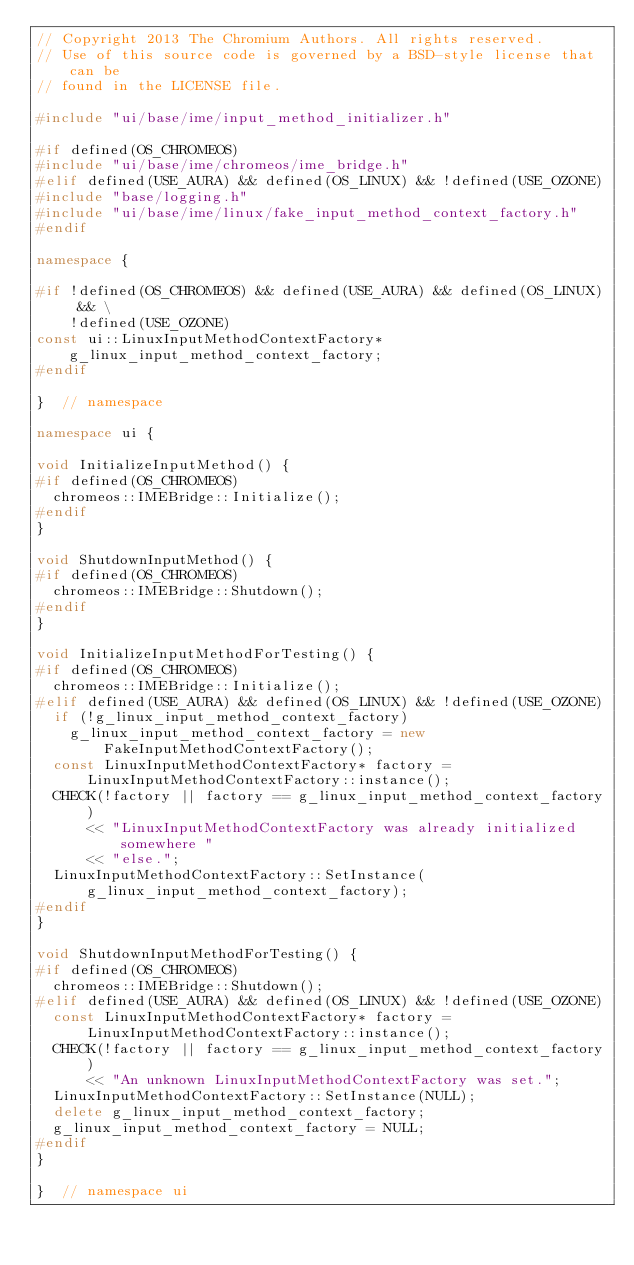Convert code to text. <code><loc_0><loc_0><loc_500><loc_500><_C++_>// Copyright 2013 The Chromium Authors. All rights reserved.
// Use of this source code is governed by a BSD-style license that can be
// found in the LICENSE file.

#include "ui/base/ime/input_method_initializer.h"

#if defined(OS_CHROMEOS)
#include "ui/base/ime/chromeos/ime_bridge.h"
#elif defined(USE_AURA) && defined(OS_LINUX) && !defined(USE_OZONE)
#include "base/logging.h"
#include "ui/base/ime/linux/fake_input_method_context_factory.h"
#endif

namespace {

#if !defined(OS_CHROMEOS) && defined(USE_AURA) && defined(OS_LINUX) && \
    !defined(USE_OZONE)
const ui::LinuxInputMethodContextFactory* g_linux_input_method_context_factory;
#endif

}  // namespace

namespace ui {

void InitializeInputMethod() {
#if defined(OS_CHROMEOS)
  chromeos::IMEBridge::Initialize();
#endif
}

void ShutdownInputMethod() {
#if defined(OS_CHROMEOS)
  chromeos::IMEBridge::Shutdown();
#endif
}

void InitializeInputMethodForTesting() {
#if defined(OS_CHROMEOS)
  chromeos::IMEBridge::Initialize();
#elif defined(USE_AURA) && defined(OS_LINUX) && !defined(USE_OZONE)
  if (!g_linux_input_method_context_factory)
    g_linux_input_method_context_factory = new FakeInputMethodContextFactory();
  const LinuxInputMethodContextFactory* factory =
      LinuxInputMethodContextFactory::instance();
  CHECK(!factory || factory == g_linux_input_method_context_factory)
      << "LinuxInputMethodContextFactory was already initialized somewhere "
      << "else.";
  LinuxInputMethodContextFactory::SetInstance(
      g_linux_input_method_context_factory);
#endif
}

void ShutdownInputMethodForTesting() {
#if defined(OS_CHROMEOS)
  chromeos::IMEBridge::Shutdown();
#elif defined(USE_AURA) && defined(OS_LINUX) && !defined(USE_OZONE)
  const LinuxInputMethodContextFactory* factory =
      LinuxInputMethodContextFactory::instance();
  CHECK(!factory || factory == g_linux_input_method_context_factory)
      << "An unknown LinuxInputMethodContextFactory was set.";
  LinuxInputMethodContextFactory::SetInstance(NULL);
  delete g_linux_input_method_context_factory;
  g_linux_input_method_context_factory = NULL;
#endif
}

}  // namespace ui
</code> 